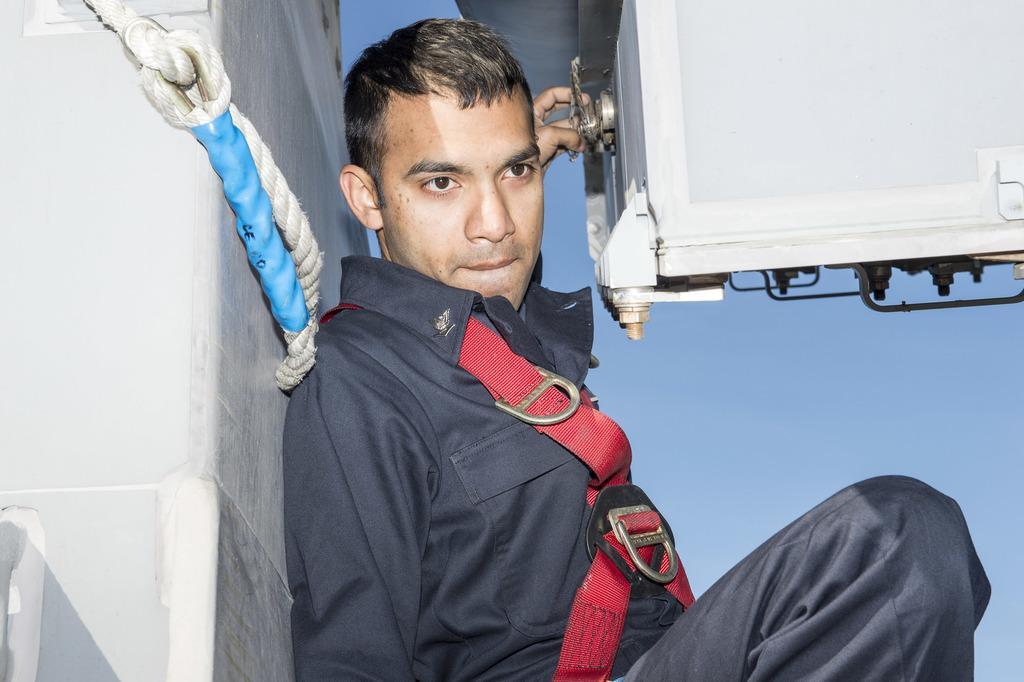Can you describe this image briefly? In this image there is a person leaning on to a wall with a rope, in front of the person there is some object. 